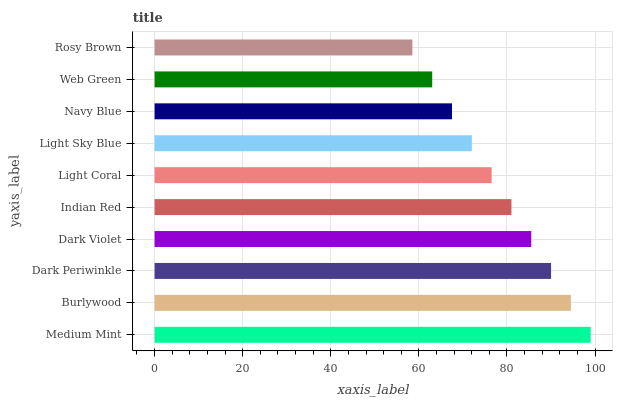Is Rosy Brown the minimum?
Answer yes or no. Yes. Is Medium Mint the maximum?
Answer yes or no. Yes. Is Burlywood the minimum?
Answer yes or no. No. Is Burlywood the maximum?
Answer yes or no. No. Is Medium Mint greater than Burlywood?
Answer yes or no. Yes. Is Burlywood less than Medium Mint?
Answer yes or no. Yes. Is Burlywood greater than Medium Mint?
Answer yes or no. No. Is Medium Mint less than Burlywood?
Answer yes or no. No. Is Indian Red the high median?
Answer yes or no. Yes. Is Light Coral the low median?
Answer yes or no. Yes. Is Dark Periwinkle the high median?
Answer yes or no. No. Is Indian Red the low median?
Answer yes or no. No. 